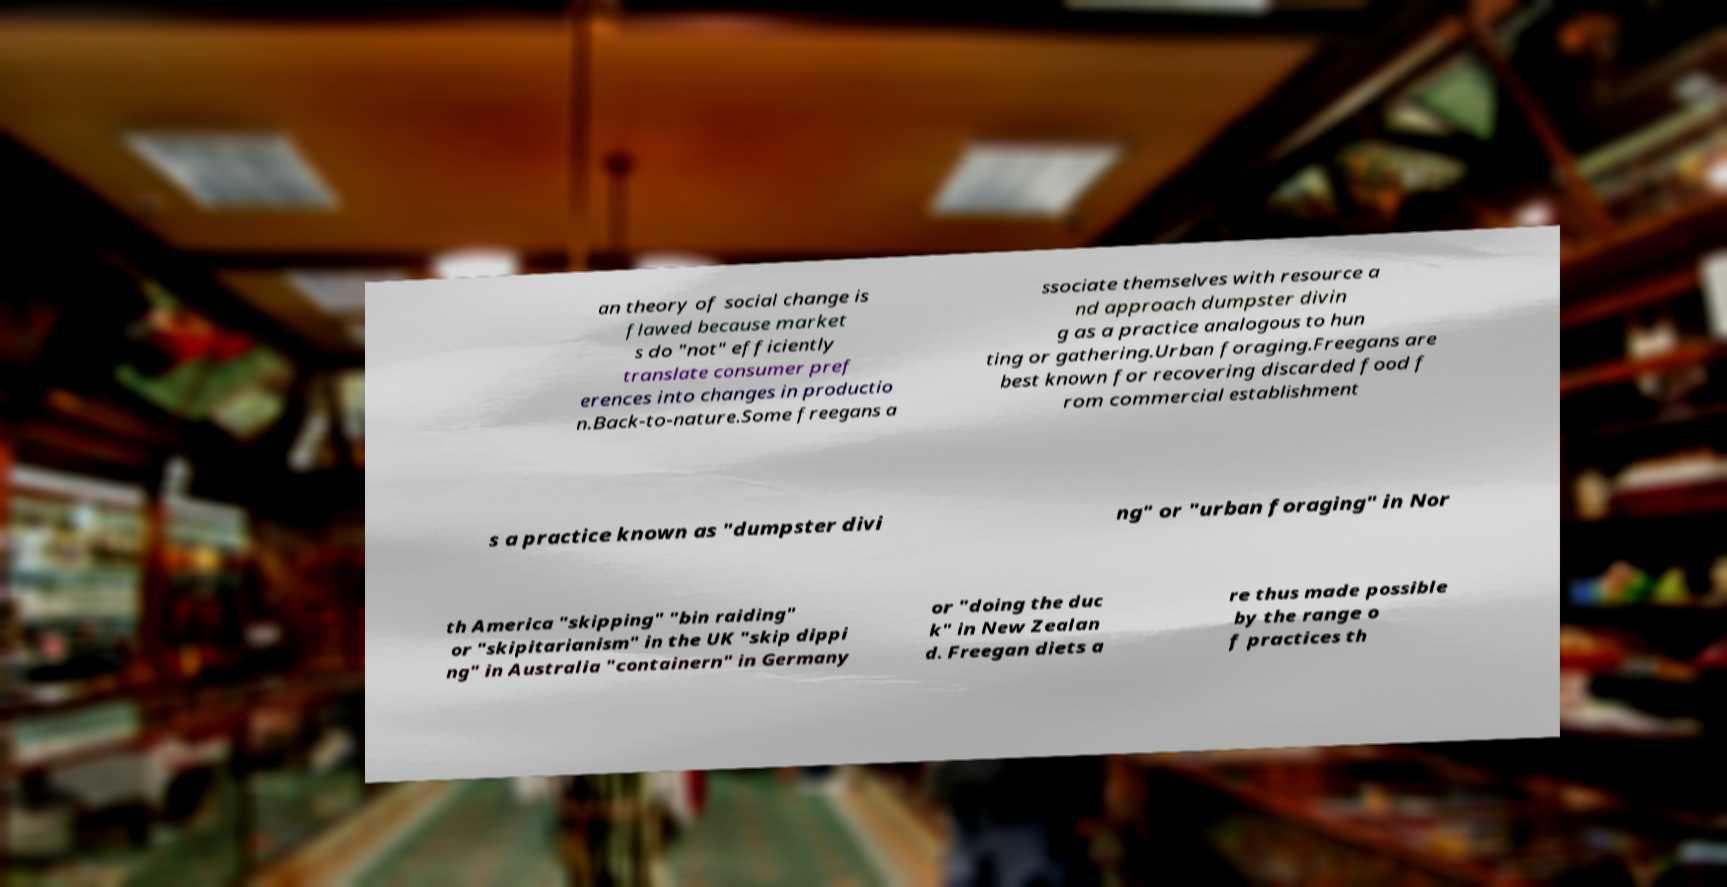I need the written content from this picture converted into text. Can you do that? an theory of social change is flawed because market s do "not" efficiently translate consumer pref erences into changes in productio n.Back-to-nature.Some freegans a ssociate themselves with resource a nd approach dumpster divin g as a practice analogous to hun ting or gathering.Urban foraging.Freegans are best known for recovering discarded food f rom commercial establishment s a practice known as "dumpster divi ng" or "urban foraging" in Nor th America "skipping" "bin raiding" or "skipitarianism" in the UK "skip dippi ng" in Australia "containern" in Germany or "doing the duc k" in New Zealan d. Freegan diets a re thus made possible by the range o f practices th 